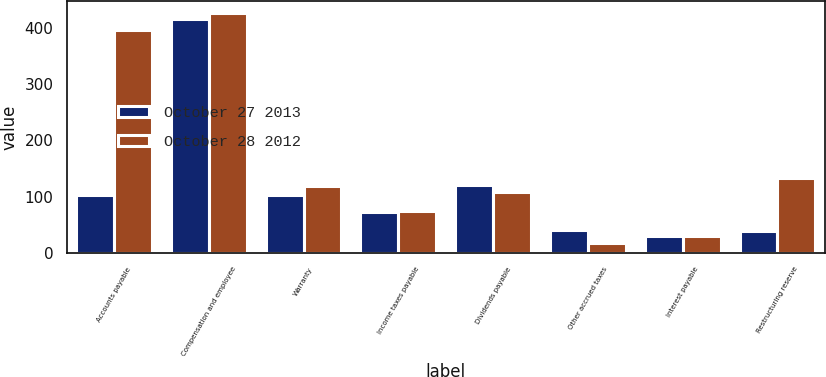Convert chart to OTSL. <chart><loc_0><loc_0><loc_500><loc_500><stacked_bar_chart><ecel><fcel>Accounts payable<fcel>Compensation and employee<fcel>Warranty<fcel>Income taxes payable<fcel>Dividends payable<fcel>Other accrued taxes<fcel>Interest payable<fcel>Restructuring reserve<nl><fcel>October 27 2013<fcel>102<fcel>417<fcel>102<fcel>73<fcel>121<fcel>41<fcel>30<fcel>39<nl><fcel>October 28 2012<fcel>396<fcel>426<fcel>119<fcel>74<fcel>108<fcel>18<fcel>30<fcel>133<nl></chart> 